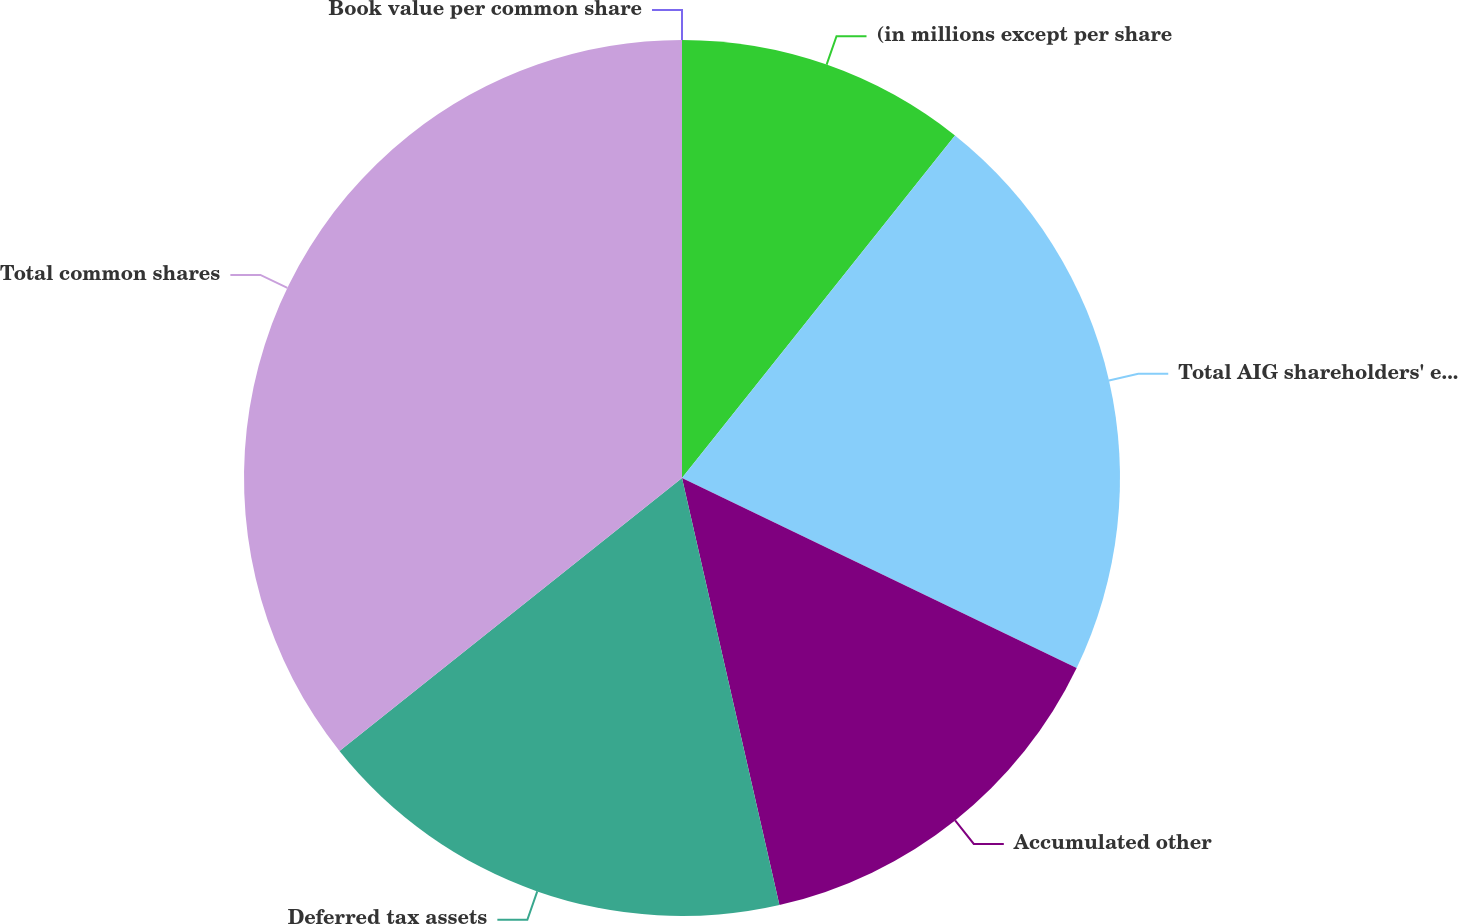<chart> <loc_0><loc_0><loc_500><loc_500><pie_chart><fcel>(in millions except per share<fcel>Total AIG shareholders' equity<fcel>Accumulated other<fcel>Deferred tax assets<fcel>Total common shares<fcel>Book value per common share<nl><fcel>10.71%<fcel>21.43%<fcel>14.29%<fcel>17.86%<fcel>35.71%<fcel>0.0%<nl></chart> 